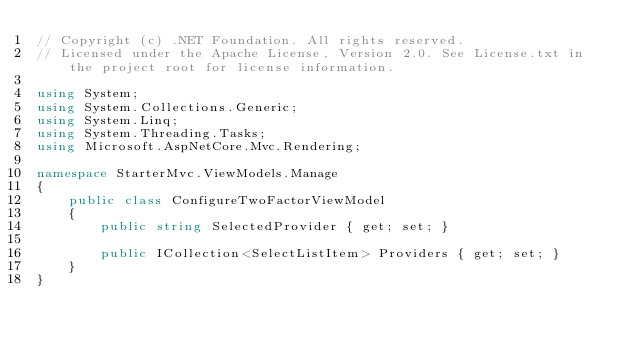<code> <loc_0><loc_0><loc_500><loc_500><_C#_>// Copyright (c) .NET Foundation. All rights reserved.
// Licensed under the Apache License, Version 2.0. See License.txt in the project root for license information.

using System;
using System.Collections.Generic;
using System.Linq;
using System.Threading.Tasks;
using Microsoft.AspNetCore.Mvc.Rendering;

namespace StarterMvc.ViewModels.Manage
{
    public class ConfigureTwoFactorViewModel
    {
        public string SelectedProvider { get; set; }

        public ICollection<SelectListItem> Providers { get; set; }
    }
}
</code> 